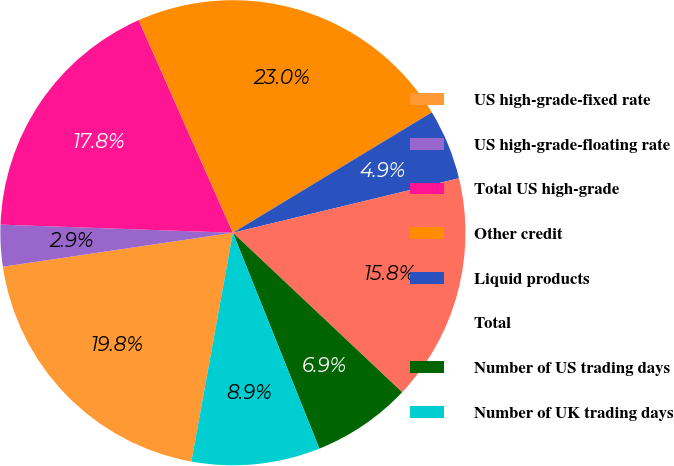Convert chart to OTSL. <chart><loc_0><loc_0><loc_500><loc_500><pie_chart><fcel>US high-grade-fixed rate<fcel>US high-grade-floating rate<fcel>Total US high-grade<fcel>Other credit<fcel>Liquid products<fcel>Total<fcel>Number of US trading days<fcel>Number of UK trading days<nl><fcel>19.81%<fcel>2.89%<fcel>17.8%<fcel>22.98%<fcel>4.9%<fcel>15.79%<fcel>6.91%<fcel>8.92%<nl></chart> 